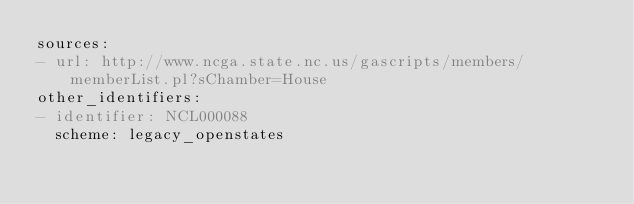<code> <loc_0><loc_0><loc_500><loc_500><_YAML_>sources:
- url: http://www.ncga.state.nc.us/gascripts/members/memberList.pl?sChamber=House
other_identifiers:
- identifier: NCL000088
  scheme: legacy_openstates
</code> 